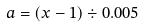<formula> <loc_0><loc_0><loc_500><loc_500>a = ( x - 1 ) \div 0 . 0 0 5</formula> 